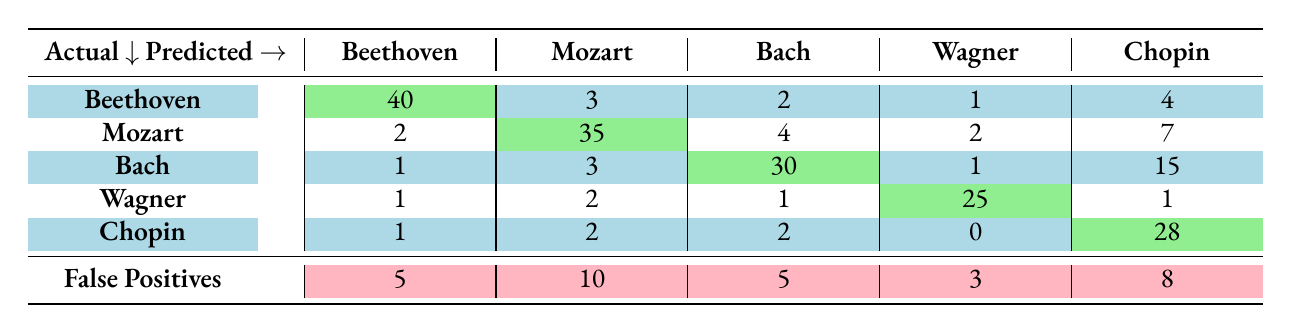What are the true positives for Beethoven? The table indicates the number of true positives, which is listed under the Beethoven column for the row of Beethoven. The value is 40.
Answer: 40 What is the total number of false positives across all composers? By adding the false positives from all composers: 5 (Beethoven) + 10 (Mozart) + 5 (Bach) + 3 (Wagner) + 8 (Chopin) = 31.
Answer: 31 How many times was Chopin incorrectly predicted as another composer? To determine this, we look at the row for Chopin and sum the values in other columns (false positive counts for Beethoven, Mozart, Bach, Wagner): 1 + 2 + 2 + 0 = 5.
Answer: 5 Which composer has the highest number of false negatives? Looking at the table for false negatives (i.e., the total number of true compositions minus true positives): Beethoven has 10, Mozart 15, Bach 20, Wagner 5, and Chopin 12. The highest is 20 for Bach.
Answer: Bach Is Johann Sebastian Bach predicted more accurately than Richard Wagner? To determine this, we compare their true positives. Bach has 30 true positives and Wagner has 25; since 30 is greater than 25, Bach is predicted more accurately.
Answer: Yes What is the average number of true positives across all composers? To find the average, we sum the true positives (40 + 35 + 30 + 25 + 28 = 158) and divide by the number of composers (5): 158 / 5 = 31.6.
Answer: 31.6 If a new model improves the predictions for Chopin, reducing false positives by 3, what will be the new false positive count for Chopin? The current false positive count for Chopin is 8. If we reduce this by 3, the new count will be 8 - 3 = 5.
Answer: 5 How many composers were predicted correctly at least 30 times? Reviewing true positives, Beethoven (40), Mozart (35), Bach (30), and Chopin (28) has 4 composers (excluding Wagner with 25).
Answer: 4 Is the accuracy of identifying Mozart greater than that of Beethoven? The true positive count for Mozart is 35 and for Beethoven is 40, so Mozart's accuracy is less than Beethoven's based on true positives.
Answer: No 